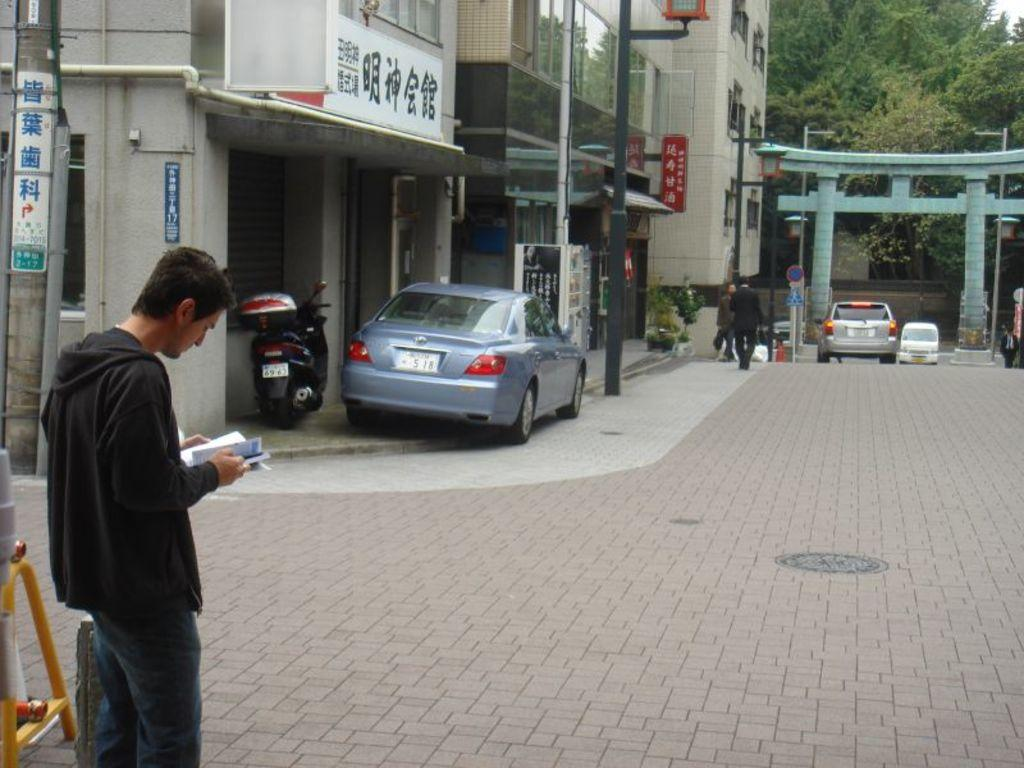What is the person on the left side of the image holding? The person is holding a book. What can be seen in the background of the image? In the background of the image, there is a pole, vehicles, an arch, persons, a tree, and the sky. How many people are visible in the image? There is one person on the left side of the image, and there are additional persons in the background, so there are at least two people visible. What size is the stop sign in the image? There is no stop sign present in the image. Can you tell me the specific request made by the person in the image? There is no indication of a request being made in the image. 